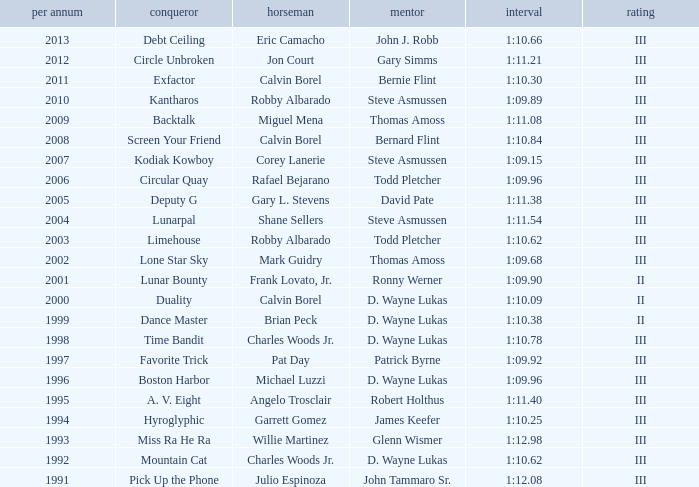What was the time for Screen Your Friend? 1:10.84. 